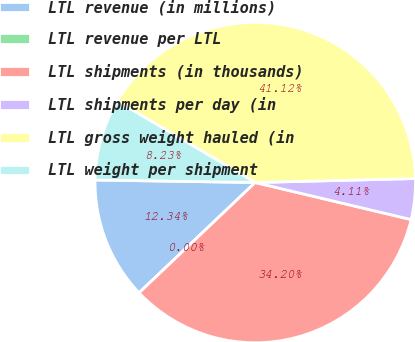Convert chart to OTSL. <chart><loc_0><loc_0><loc_500><loc_500><pie_chart><fcel>LTL revenue (in millions)<fcel>LTL revenue per LTL<fcel>LTL shipments (in thousands)<fcel>LTL shipments per day (in<fcel>LTL gross weight hauled (in<fcel>LTL weight per shipment<nl><fcel>12.34%<fcel>0.0%<fcel>34.2%<fcel>4.11%<fcel>41.12%<fcel>8.23%<nl></chart> 